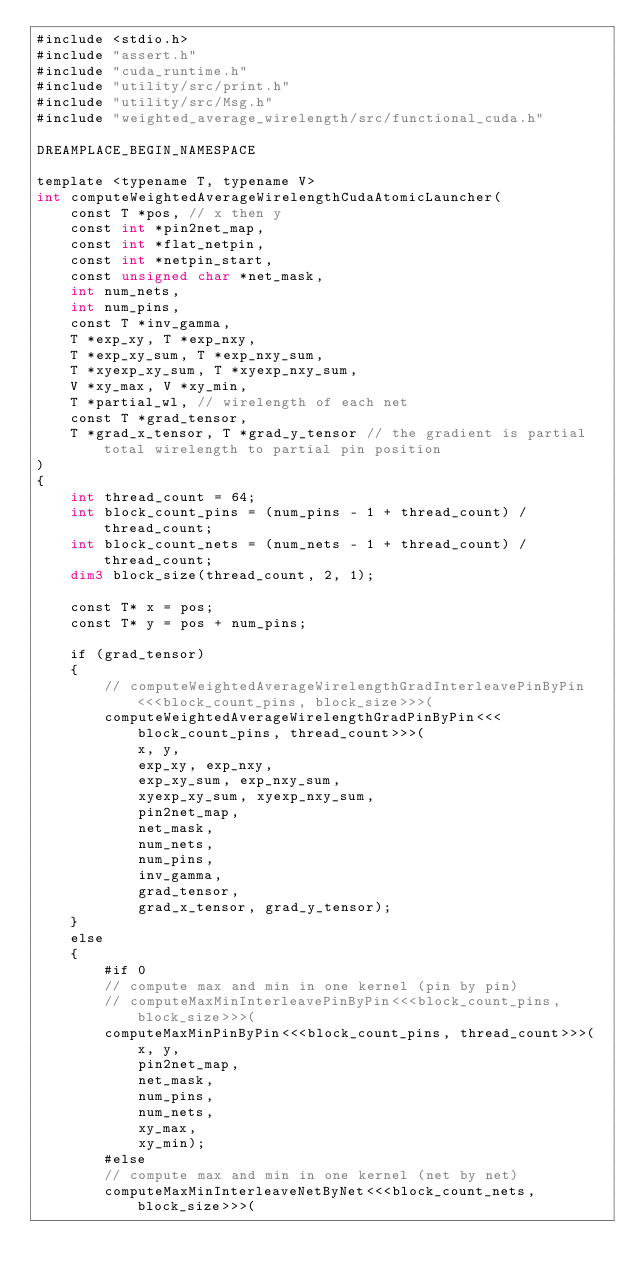<code> <loc_0><loc_0><loc_500><loc_500><_Cuda_>#include <stdio.h>
#include "assert.h"
#include "cuda_runtime.h"
#include "utility/src/print.h"
#include "utility/src/Msg.h"
#include "weighted_average_wirelength/src/functional_cuda.h"

DREAMPLACE_BEGIN_NAMESPACE

template <typename T, typename V>
int computeWeightedAverageWirelengthCudaAtomicLauncher(
    const T *pos, // x then y
    const int *pin2net_map,
    const int *flat_netpin,
    const int *netpin_start,
    const unsigned char *net_mask,
    int num_nets,
    int num_pins,
    const T *inv_gamma,
    T *exp_xy, T *exp_nxy,
    T *exp_xy_sum, T *exp_nxy_sum,
    T *xyexp_xy_sum, T *xyexp_nxy_sum,
    V *xy_max, V *xy_min,
    T *partial_wl, // wirelength of each net
    const T *grad_tensor,
    T *grad_x_tensor, T *grad_y_tensor // the gradient is partial total wirelength to partial pin position
)
{
    int thread_count = 64;
    int block_count_pins = (num_pins - 1 + thread_count) / thread_count;
    int block_count_nets = (num_nets - 1 + thread_count) / thread_count;
    dim3 block_size(thread_count, 2, 1);

    const T* x = pos;
    const T* y = pos + num_pins;

    if (grad_tensor)
    {
        // computeWeightedAverageWirelengthGradInterleavePinByPin<<<block_count_pins, block_size>>>(
        computeWeightedAverageWirelengthGradPinByPin<<<block_count_pins, thread_count>>>(
            x, y,
            exp_xy, exp_nxy,
            exp_xy_sum, exp_nxy_sum,
            xyexp_xy_sum, xyexp_nxy_sum,
            pin2net_map,
            net_mask,
            num_nets,
            num_pins,
            inv_gamma,
            grad_tensor,
            grad_x_tensor, grad_y_tensor);
    }
    else
    {
        #if 0
        // compute max and min in one kernel (pin by pin)
        // computeMaxMinInterleavePinByPin<<<block_count_pins, block_size>>>(
        computeMaxMinPinByPin<<<block_count_pins, thread_count>>>(
            x, y,
            pin2net_map,
            net_mask,
            num_pins,
            num_nets,
            xy_max,
            xy_min);
        #else
        // compute max and min in one kernel (net by net)
        computeMaxMinInterleaveNetByNet<<<block_count_nets, block_size>>>(</code> 